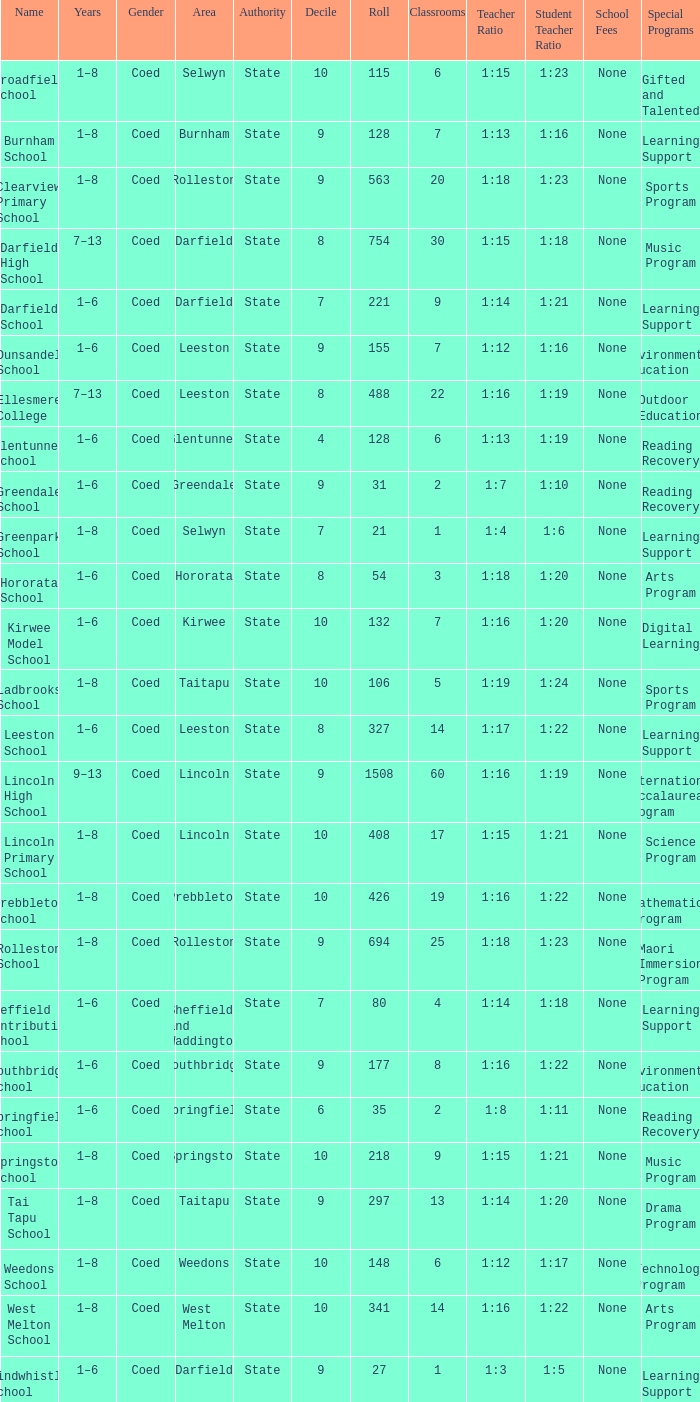What is the total of the roll with a Decile of 8, and an Area of hororata? 54.0. Could you parse the entire table as a dict? {'header': ['Name', 'Years', 'Gender', 'Area', 'Authority', 'Decile', 'Roll', 'Classrooms', 'Teacher Ratio', 'Student Teacher Ratio', 'School Fees', 'Special Programs '], 'rows': [['Broadfield School', '1–8', 'Coed', 'Selwyn', 'State', '10', '115', '6', '1:15', '1:23', 'None', 'Gifted and Talented '], ['Burnham School', '1–8', 'Coed', 'Burnham', 'State', '9', '128', '7', '1:13', '1:16', 'None', 'Learning Support '], ['Clearview Primary School', '1–8', 'Coed', 'Rolleston', 'State', '9', '563', '20', '1:18', '1:23', 'None', 'Sports Program '], ['Darfield High School', '7–13', 'Coed', 'Darfield', 'State', '8', '754', '30', '1:15', '1:18', 'None', 'Music Program '], ['Darfield School', '1–6', 'Coed', 'Darfield', 'State', '7', '221', '9', '1:14', '1:21', 'None', 'Learning Support '], ['Dunsandel School', '1–6', 'Coed', 'Leeston', 'State', '9', '155', '7', '1:12', '1:16', 'None', 'Environmental Education '], ['Ellesmere College', '7–13', 'Coed', 'Leeston', 'State', '8', '488', '22', '1:16', '1:19', 'None', 'Outdoor Education '], ['Glentunnel School', '1–6', 'Coed', 'Glentunnel', 'State', '4', '128', '6', '1:13', '1:19', 'None', 'Reading Recovery '], ['Greendale School', '1–6', 'Coed', 'Greendale', 'State', '9', '31', '2', '1:7', '1:10', 'None', 'Reading Recovery '], ['Greenpark School', '1–8', 'Coed', 'Selwyn', 'State', '7', '21', '1', '1:4', '1:6', 'None', 'Learning Support '], ['Hororata School', '1–6', 'Coed', 'Hororata', 'State', '8', '54', '3', '1:18', '1:20', 'None', 'Arts Program '], ['Kirwee Model School', '1–6', 'Coed', 'Kirwee', 'State', '10', '132', '7', '1:16', '1:20', 'None', 'Digital Learning '], ['Ladbrooks School', '1–8', 'Coed', 'Taitapu', 'State', '10', '106', '5', '1:19', '1:24', 'None', 'Sports Program '], ['Leeston School', '1–6', 'Coed', 'Leeston', 'State', '8', '327', '14', '1:17', '1:22', 'None', 'Learning Support '], ['Lincoln High School', '9–13', 'Coed', 'Lincoln', 'State', '9', '1508', '60', '1:16', '1:19', 'None', 'International Baccalaureate Program '], ['Lincoln Primary School', '1–8', 'Coed', 'Lincoln', 'State', '10', '408', '17', '1:15', '1:21', 'None', 'Science Program '], ['Prebbleton School', '1–8', 'Coed', 'Prebbleton', 'State', '10', '426', '19', '1:16', '1:22', 'None', 'Mathematics Program '], ['Rolleston School', '1–8', 'Coed', 'Rolleston', 'State', '9', '694', '25', '1:18', '1:23', 'None', 'Maori Immersion Program '], ['Sheffield Contributing School', '1–6', 'Coed', 'Sheffield and Waddington', 'State', '7', '80', '4', '1:14', '1:18', 'None', 'Learning Support '], ['Southbridge School', '1–6', 'Coed', 'Southbridge', 'State', '9', '177', '8', '1:16', '1:22', 'None', 'Environmental Education '], ['Springfield School', '1–6', 'Coed', 'Springfield', 'State', '6', '35', '2', '1:8', '1:11', 'None', 'Reading Recovery '], ['Springston School', '1–8', 'Coed', 'Springston', 'State', '10', '218', '9', '1:15', '1:21', 'None', 'Music Program '], ['Tai Tapu School', '1–8', 'Coed', 'Taitapu', 'State', '9', '297', '13', '1:14', '1:20', 'None', 'Drama Program '], ['Weedons School', '1–8', 'Coed', 'Weedons', 'State', '10', '148', '6', '1:12', '1:17', 'None', 'Technology Program '], ['West Melton School', '1–8', 'Coed', 'West Melton', 'State', '10', '341', '14', '1:16', '1:22', 'None', 'Arts Program '], ['Windwhistle School', '1–6', 'Coed', 'Darfield', 'State', '9', '27', '1', '1:3', '1:5', 'None', 'Learning Support']]} 